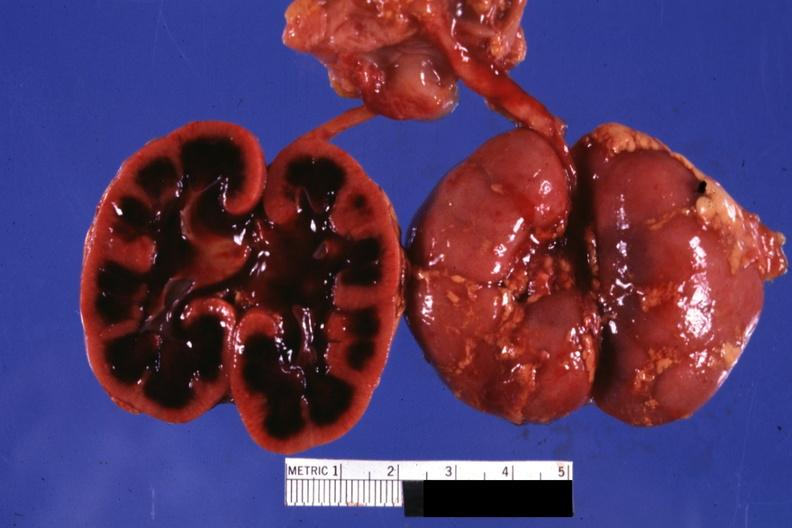where is this?
Answer the question using a single word or phrase. Urinary 